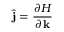<formula> <loc_0><loc_0><loc_500><loc_500>{ \hat { j } } = \frac { \partial H } { \partial { k } }</formula> 